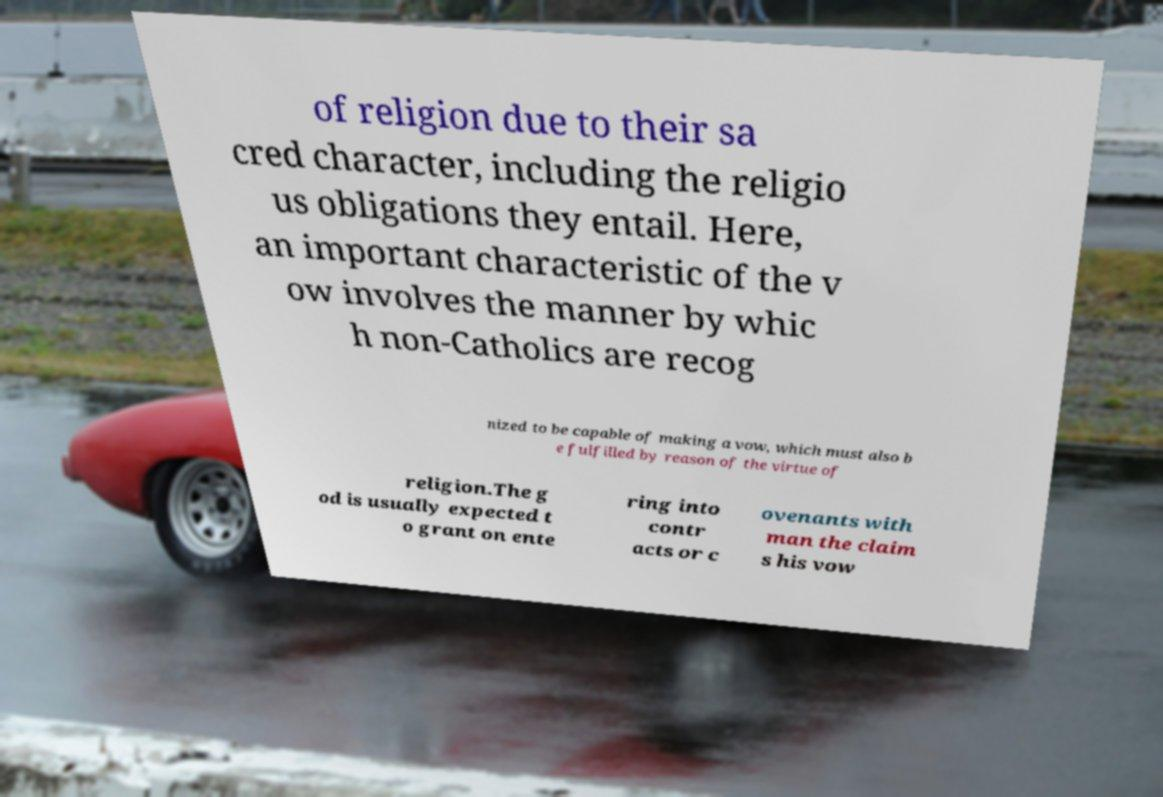Please read and relay the text visible in this image. What does it say? of religion due to their sa cred character, including the religio us obligations they entail. Here, an important characteristic of the v ow involves the manner by whic h non-Catholics are recog nized to be capable of making a vow, which must also b e fulfilled by reason of the virtue of religion.The g od is usually expected t o grant on ente ring into contr acts or c ovenants with man the claim s his vow 